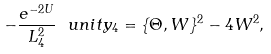Convert formula to latex. <formula><loc_0><loc_0><loc_500><loc_500>- \frac { e ^ { - 2 U } } { L _ { 4 } ^ { 2 } } \ u n i t y _ { 4 } = \{ \Theta , W \} ^ { 2 } - 4 W ^ { 2 } ,</formula> 